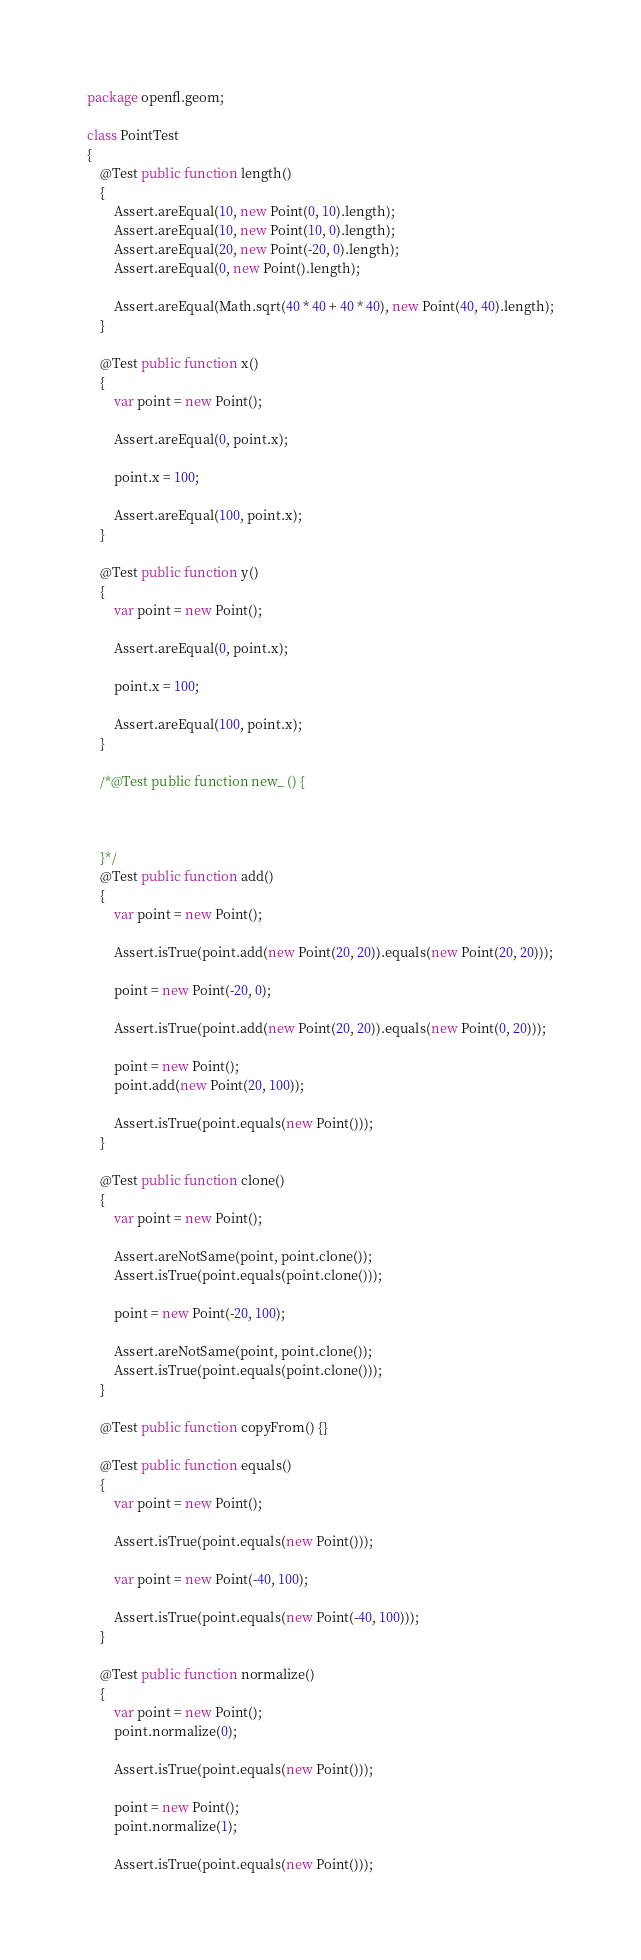<code> <loc_0><loc_0><loc_500><loc_500><_Haxe_>package openfl.geom;

class PointTest
{
	@Test public function length()
	{
		Assert.areEqual(10, new Point(0, 10).length);
		Assert.areEqual(10, new Point(10, 0).length);
		Assert.areEqual(20, new Point(-20, 0).length);
		Assert.areEqual(0, new Point().length);

		Assert.areEqual(Math.sqrt(40 * 40 + 40 * 40), new Point(40, 40).length);
	}

	@Test public function x()
	{
		var point = new Point();

		Assert.areEqual(0, point.x);

		point.x = 100;

		Assert.areEqual(100, point.x);
	}

	@Test public function y()
	{
		var point = new Point();

		Assert.areEqual(0, point.x);

		point.x = 100;

		Assert.areEqual(100, point.x);
	}

	/*@Test public function new_ () {



	}*/
	@Test public function add()
	{
		var point = new Point();

		Assert.isTrue(point.add(new Point(20, 20)).equals(new Point(20, 20)));

		point = new Point(-20, 0);

		Assert.isTrue(point.add(new Point(20, 20)).equals(new Point(0, 20)));

		point = new Point();
		point.add(new Point(20, 100));

		Assert.isTrue(point.equals(new Point()));
	}

	@Test public function clone()
	{
		var point = new Point();

		Assert.areNotSame(point, point.clone());
		Assert.isTrue(point.equals(point.clone()));

		point = new Point(-20, 100);

		Assert.areNotSame(point, point.clone());
		Assert.isTrue(point.equals(point.clone()));
	}

	@Test public function copyFrom() {}

	@Test public function equals()
	{
		var point = new Point();

		Assert.isTrue(point.equals(new Point()));

		var point = new Point(-40, 100);

		Assert.isTrue(point.equals(new Point(-40, 100)));
	}

	@Test public function normalize()
	{
		var point = new Point();
		point.normalize(0);

		Assert.isTrue(point.equals(new Point()));

		point = new Point();
		point.normalize(1);

		Assert.isTrue(point.equals(new Point()));
</code> 